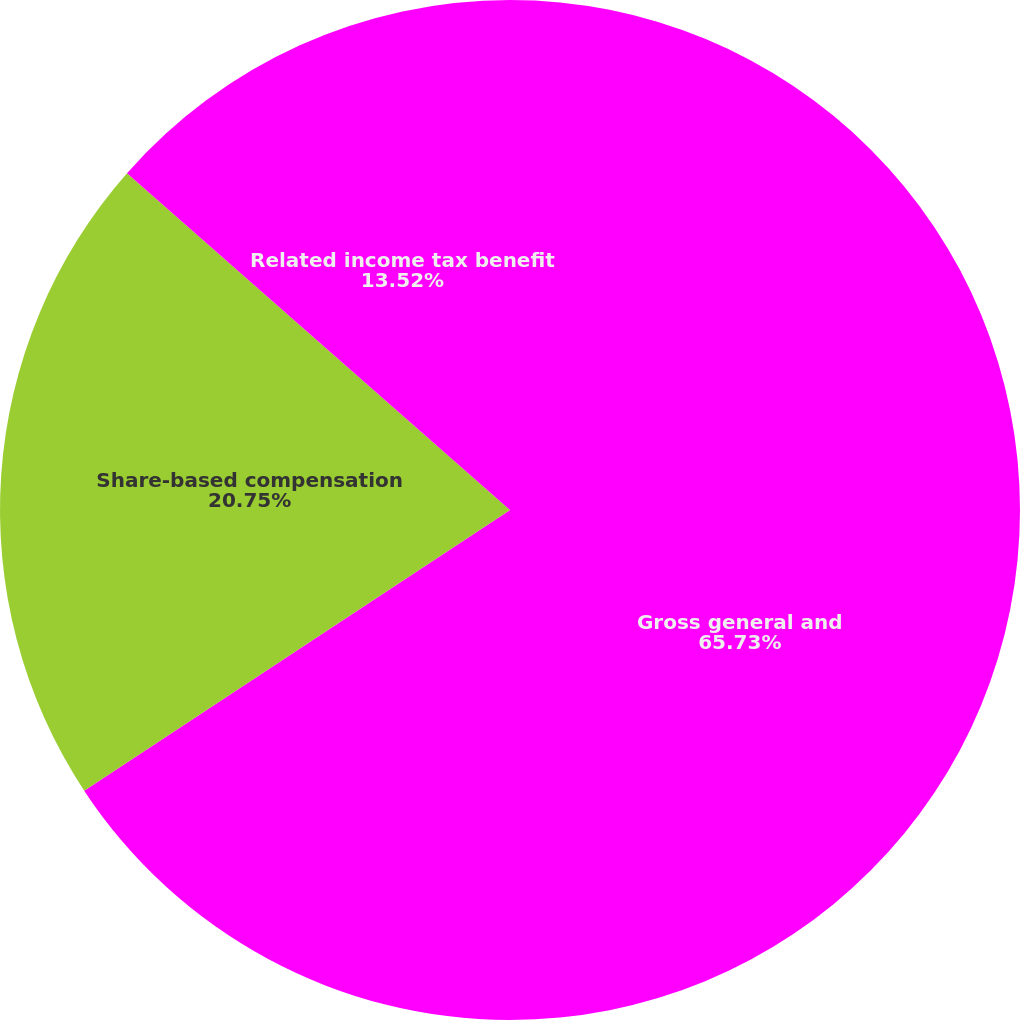Convert chart. <chart><loc_0><loc_0><loc_500><loc_500><pie_chart><fcel>Gross general and<fcel>Share-based compensation<fcel>Related income tax benefit<nl><fcel>65.72%<fcel>20.75%<fcel>13.52%<nl></chart> 